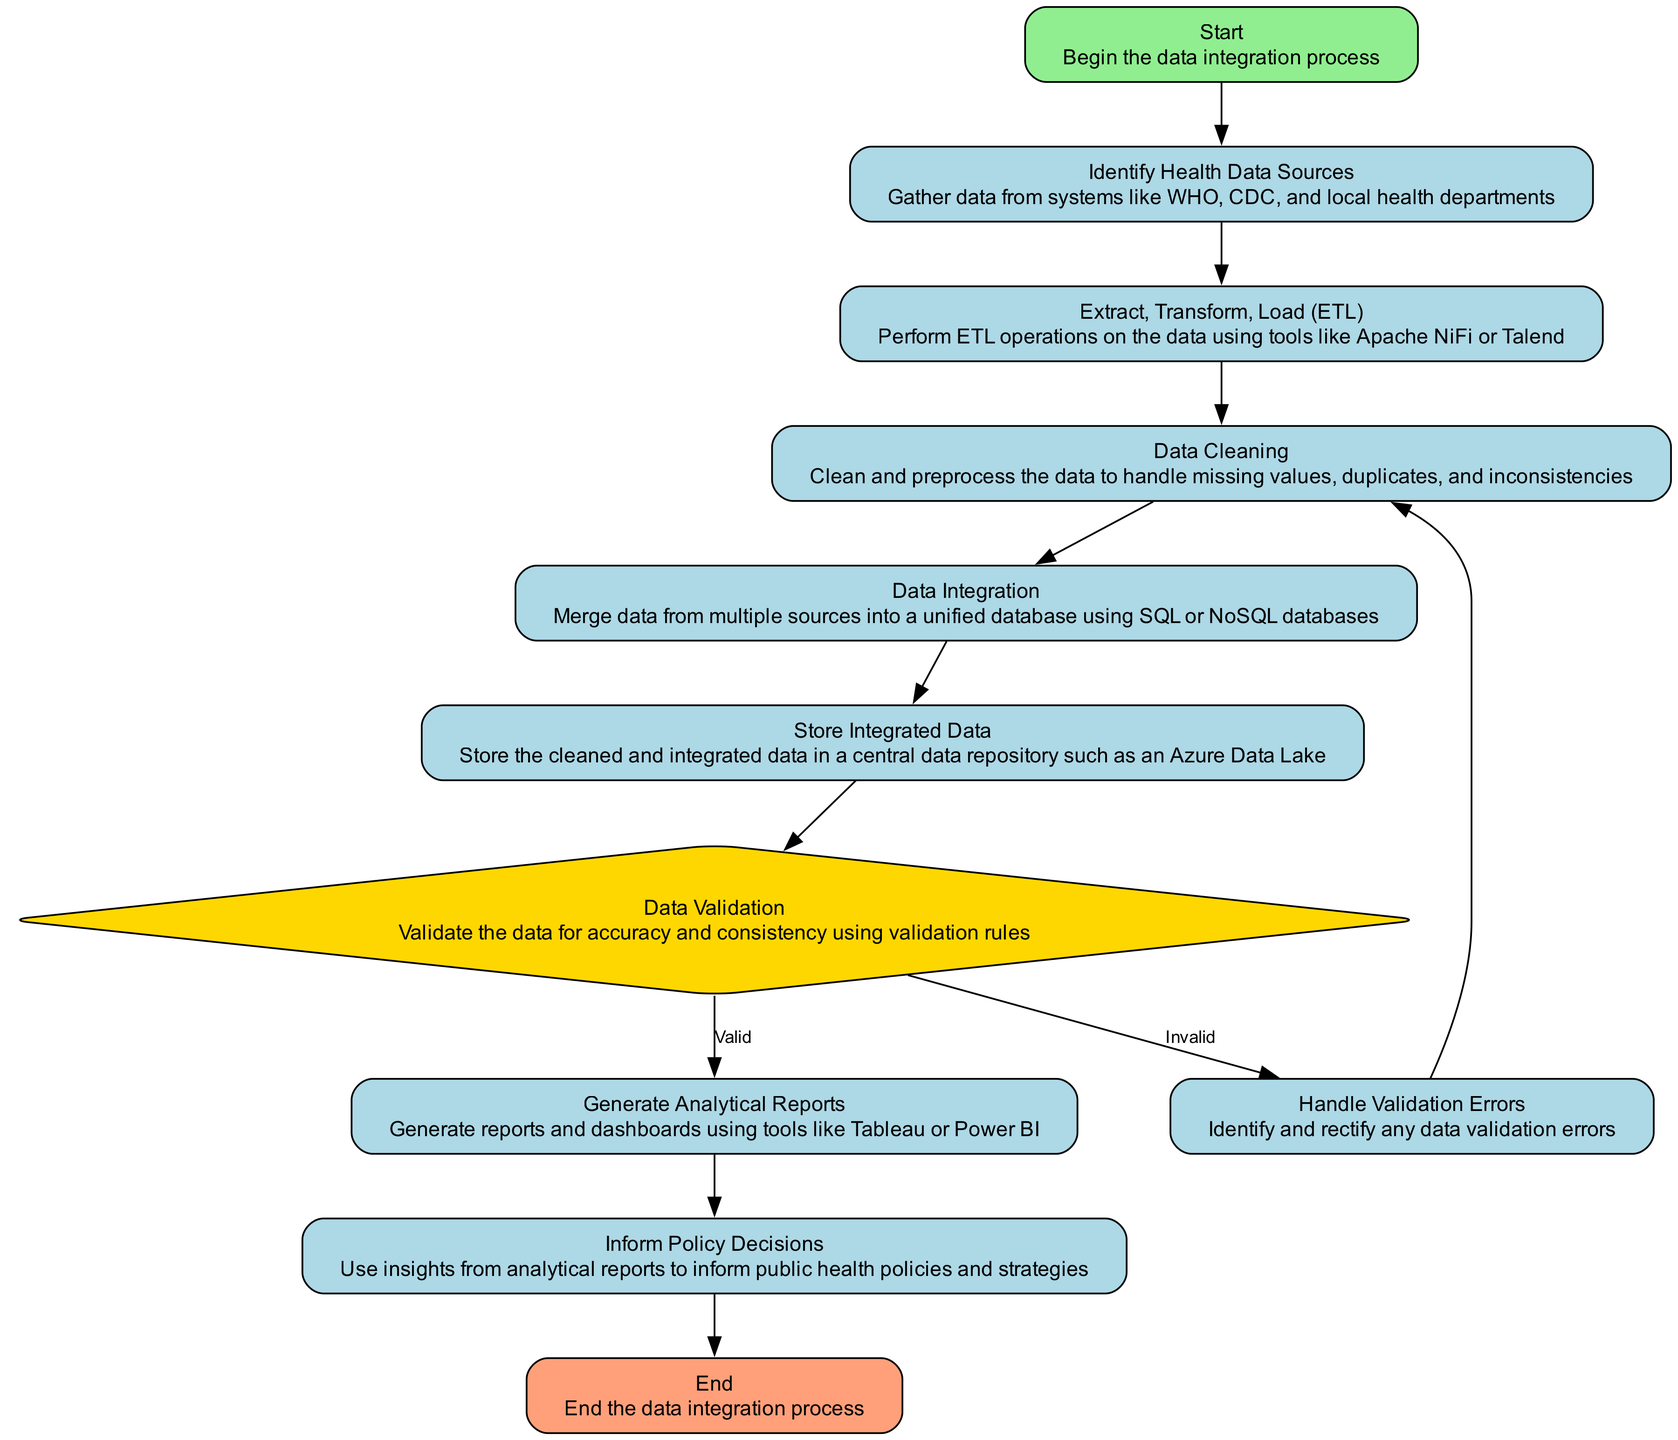What is the first step in the diagram? The diagram starts with the 'Start' process, indicating the initiation of the data integration process.
Answer: Start How many process nodes are in the diagram? There are six process nodes: Identify Health Data Sources, Extract, Transform, Load (ETL), Data Cleaning, Data Integration, Store Integrated Data, Generate Analytical Reports, Inform Policy Decisions.
Answer: Six What happens if the data validation is invalid? If the data validation is invalid, the process moves to the 'Handle Validation Errors' node, where errors are identified and rectified.
Answer: Handle Validation Errors What is the final output of the process? The final step of the process is labeled 'End', indicating the completion of the data integration process.
Answer: End Which tool is mentioned for performing ETL operations? The diagram indicates the use of tools like Apache NiFi or Talend for performing ETL operations.
Answer: Apache NiFi or Talend What is done after the data is validated? Once the data is validated, analytical reports are generated using tools like Tableau or Power BI.
Answer: Generate Analytical Reports What step follows 'Store Integrated Data'? After storing integrated data, the next step is 'Data Validation' to ensure accuracy and consistency of the data.
Answer: Data Validation What node deals with cleaning the data? The node labeled 'Data Cleaning' specifically handles the cleaning and preprocessing of the data.
Answer: Data Cleaning What is the role of 'Inform Policy Decisions'? The 'Inform Policy Decisions' process uses insights from analytical reports to guide public health policies and strategies.
Answer: Use insights to inform policies 